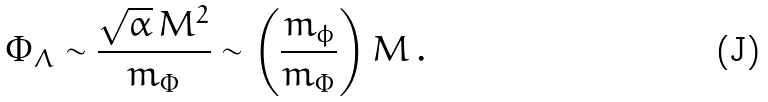<formula> <loc_0><loc_0><loc_500><loc_500>\Phi _ { \Lambda } \sim \frac { \sqrt { \alpha } \, M ^ { 2 } } { m _ { \Phi } } \sim \left ( \frac { m _ { \phi } } { m _ { \Phi } } \right ) M \, .</formula> 